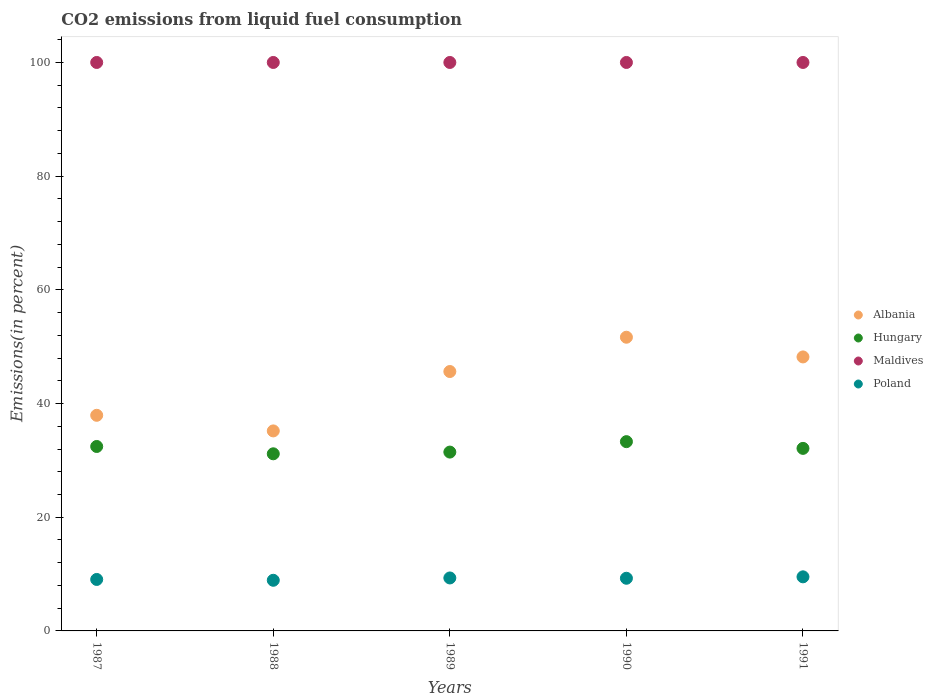How many different coloured dotlines are there?
Offer a very short reply. 4. What is the total CO2 emitted in Albania in 1991?
Offer a very short reply. 48.2. Across all years, what is the maximum total CO2 emitted in Hungary?
Your answer should be compact. 33.3. Across all years, what is the minimum total CO2 emitted in Hungary?
Offer a terse response. 31.16. What is the total total CO2 emitted in Hungary in the graph?
Your response must be concise. 160.47. What is the difference between the total CO2 emitted in Albania in 1988 and that in 1991?
Give a very brief answer. -13.01. What is the difference between the total CO2 emitted in Maldives in 1988 and the total CO2 emitted in Poland in 1989?
Your answer should be compact. 90.68. What is the average total CO2 emitted in Albania per year?
Provide a succinct answer. 43.72. In the year 1989, what is the difference between the total CO2 emitted in Poland and total CO2 emitted in Maldives?
Make the answer very short. -90.68. In how many years, is the total CO2 emitted in Albania greater than 80 %?
Keep it short and to the point. 0. What is the ratio of the total CO2 emitted in Poland in 1989 to that in 1991?
Offer a terse response. 0.98. Is the total CO2 emitted in Maldives in 1988 less than that in 1990?
Offer a very short reply. No. What is the difference between the highest and the second highest total CO2 emitted in Hungary?
Offer a terse response. 0.85. What is the difference between the highest and the lowest total CO2 emitted in Maldives?
Your response must be concise. 0. Does the total CO2 emitted in Poland monotonically increase over the years?
Your answer should be compact. No. Is the total CO2 emitted in Albania strictly greater than the total CO2 emitted in Hungary over the years?
Your response must be concise. Yes. Is the total CO2 emitted in Maldives strictly less than the total CO2 emitted in Poland over the years?
Give a very brief answer. No. Are the values on the major ticks of Y-axis written in scientific E-notation?
Your response must be concise. No. Does the graph contain any zero values?
Ensure brevity in your answer.  No. Does the graph contain grids?
Make the answer very short. No. Where does the legend appear in the graph?
Your answer should be compact. Center right. How are the legend labels stacked?
Offer a very short reply. Vertical. What is the title of the graph?
Provide a succinct answer. CO2 emissions from liquid fuel consumption. Does "Gambia, The" appear as one of the legend labels in the graph?
Your answer should be compact. No. What is the label or title of the X-axis?
Make the answer very short. Years. What is the label or title of the Y-axis?
Provide a short and direct response. Emissions(in percent). What is the Emissions(in percent) of Albania in 1987?
Provide a short and direct response. 37.93. What is the Emissions(in percent) of Hungary in 1987?
Make the answer very short. 32.45. What is the Emissions(in percent) in Poland in 1987?
Ensure brevity in your answer.  9.05. What is the Emissions(in percent) in Albania in 1988?
Your answer should be compact. 35.19. What is the Emissions(in percent) in Hungary in 1988?
Provide a short and direct response. 31.16. What is the Emissions(in percent) in Maldives in 1988?
Offer a very short reply. 100. What is the Emissions(in percent) of Poland in 1988?
Offer a very short reply. 8.91. What is the Emissions(in percent) of Albania in 1989?
Provide a succinct answer. 45.63. What is the Emissions(in percent) of Hungary in 1989?
Your answer should be compact. 31.46. What is the Emissions(in percent) in Poland in 1989?
Your answer should be compact. 9.32. What is the Emissions(in percent) in Albania in 1990?
Keep it short and to the point. 51.67. What is the Emissions(in percent) in Hungary in 1990?
Offer a very short reply. 33.3. What is the Emissions(in percent) in Poland in 1990?
Offer a terse response. 9.26. What is the Emissions(in percent) of Albania in 1991?
Ensure brevity in your answer.  48.2. What is the Emissions(in percent) in Hungary in 1991?
Provide a short and direct response. 32.11. What is the Emissions(in percent) in Poland in 1991?
Make the answer very short. 9.51. Across all years, what is the maximum Emissions(in percent) of Albania?
Your response must be concise. 51.67. Across all years, what is the maximum Emissions(in percent) in Hungary?
Provide a succinct answer. 33.3. Across all years, what is the maximum Emissions(in percent) of Poland?
Provide a short and direct response. 9.51. Across all years, what is the minimum Emissions(in percent) in Albania?
Offer a very short reply. 35.19. Across all years, what is the minimum Emissions(in percent) in Hungary?
Offer a very short reply. 31.16. Across all years, what is the minimum Emissions(in percent) in Poland?
Make the answer very short. 8.91. What is the total Emissions(in percent) of Albania in the graph?
Your answer should be compact. 218.61. What is the total Emissions(in percent) of Hungary in the graph?
Offer a very short reply. 160.47. What is the total Emissions(in percent) of Maldives in the graph?
Your answer should be compact. 500. What is the total Emissions(in percent) in Poland in the graph?
Your answer should be compact. 46.06. What is the difference between the Emissions(in percent) in Albania in 1987 and that in 1988?
Your answer should be very brief. 2.75. What is the difference between the Emissions(in percent) in Hungary in 1987 and that in 1988?
Your answer should be compact. 1.29. What is the difference between the Emissions(in percent) in Poland in 1987 and that in 1988?
Give a very brief answer. 0.15. What is the difference between the Emissions(in percent) of Albania in 1987 and that in 1989?
Give a very brief answer. -7.7. What is the difference between the Emissions(in percent) of Hungary in 1987 and that in 1989?
Provide a short and direct response. 0.99. What is the difference between the Emissions(in percent) in Maldives in 1987 and that in 1989?
Give a very brief answer. 0. What is the difference between the Emissions(in percent) in Poland in 1987 and that in 1989?
Keep it short and to the point. -0.26. What is the difference between the Emissions(in percent) in Albania in 1987 and that in 1990?
Keep it short and to the point. -13.73. What is the difference between the Emissions(in percent) of Hungary in 1987 and that in 1990?
Your response must be concise. -0.85. What is the difference between the Emissions(in percent) in Maldives in 1987 and that in 1990?
Offer a terse response. 0. What is the difference between the Emissions(in percent) in Poland in 1987 and that in 1990?
Offer a very short reply. -0.21. What is the difference between the Emissions(in percent) in Albania in 1987 and that in 1991?
Ensure brevity in your answer.  -10.27. What is the difference between the Emissions(in percent) of Hungary in 1987 and that in 1991?
Give a very brief answer. 0.33. What is the difference between the Emissions(in percent) in Maldives in 1987 and that in 1991?
Keep it short and to the point. 0. What is the difference between the Emissions(in percent) of Poland in 1987 and that in 1991?
Offer a very short reply. -0.46. What is the difference between the Emissions(in percent) of Albania in 1988 and that in 1989?
Ensure brevity in your answer.  -10.45. What is the difference between the Emissions(in percent) of Hungary in 1988 and that in 1989?
Provide a short and direct response. -0.3. What is the difference between the Emissions(in percent) in Maldives in 1988 and that in 1989?
Keep it short and to the point. 0. What is the difference between the Emissions(in percent) in Poland in 1988 and that in 1989?
Give a very brief answer. -0.41. What is the difference between the Emissions(in percent) in Albania in 1988 and that in 1990?
Make the answer very short. -16.48. What is the difference between the Emissions(in percent) of Hungary in 1988 and that in 1990?
Give a very brief answer. -2.14. What is the difference between the Emissions(in percent) of Poland in 1988 and that in 1990?
Your response must be concise. -0.36. What is the difference between the Emissions(in percent) in Albania in 1988 and that in 1991?
Your answer should be compact. -13.01. What is the difference between the Emissions(in percent) in Hungary in 1988 and that in 1991?
Offer a terse response. -0.95. What is the difference between the Emissions(in percent) in Maldives in 1988 and that in 1991?
Your answer should be compact. 0. What is the difference between the Emissions(in percent) in Poland in 1988 and that in 1991?
Make the answer very short. -0.61. What is the difference between the Emissions(in percent) in Albania in 1989 and that in 1990?
Provide a short and direct response. -6.03. What is the difference between the Emissions(in percent) in Hungary in 1989 and that in 1990?
Ensure brevity in your answer.  -1.84. What is the difference between the Emissions(in percent) of Poland in 1989 and that in 1990?
Provide a short and direct response. 0.05. What is the difference between the Emissions(in percent) of Albania in 1989 and that in 1991?
Make the answer very short. -2.57. What is the difference between the Emissions(in percent) in Hungary in 1989 and that in 1991?
Make the answer very short. -0.65. What is the difference between the Emissions(in percent) of Maldives in 1989 and that in 1991?
Make the answer very short. 0. What is the difference between the Emissions(in percent) in Poland in 1989 and that in 1991?
Provide a succinct answer. -0.2. What is the difference between the Emissions(in percent) in Albania in 1990 and that in 1991?
Offer a terse response. 3.47. What is the difference between the Emissions(in percent) of Hungary in 1990 and that in 1991?
Give a very brief answer. 1.18. What is the difference between the Emissions(in percent) in Maldives in 1990 and that in 1991?
Your answer should be compact. 0. What is the difference between the Emissions(in percent) in Poland in 1990 and that in 1991?
Offer a very short reply. -0.25. What is the difference between the Emissions(in percent) in Albania in 1987 and the Emissions(in percent) in Hungary in 1988?
Make the answer very short. 6.77. What is the difference between the Emissions(in percent) of Albania in 1987 and the Emissions(in percent) of Maldives in 1988?
Offer a very short reply. -62.07. What is the difference between the Emissions(in percent) in Albania in 1987 and the Emissions(in percent) in Poland in 1988?
Provide a short and direct response. 29.02. What is the difference between the Emissions(in percent) in Hungary in 1987 and the Emissions(in percent) in Maldives in 1988?
Your answer should be compact. -67.55. What is the difference between the Emissions(in percent) in Hungary in 1987 and the Emissions(in percent) in Poland in 1988?
Offer a very short reply. 23.54. What is the difference between the Emissions(in percent) in Maldives in 1987 and the Emissions(in percent) in Poland in 1988?
Make the answer very short. 91.09. What is the difference between the Emissions(in percent) in Albania in 1987 and the Emissions(in percent) in Hungary in 1989?
Offer a very short reply. 6.47. What is the difference between the Emissions(in percent) of Albania in 1987 and the Emissions(in percent) of Maldives in 1989?
Your answer should be very brief. -62.07. What is the difference between the Emissions(in percent) of Albania in 1987 and the Emissions(in percent) of Poland in 1989?
Your response must be concise. 28.61. What is the difference between the Emissions(in percent) in Hungary in 1987 and the Emissions(in percent) in Maldives in 1989?
Ensure brevity in your answer.  -67.55. What is the difference between the Emissions(in percent) in Hungary in 1987 and the Emissions(in percent) in Poland in 1989?
Keep it short and to the point. 23.13. What is the difference between the Emissions(in percent) in Maldives in 1987 and the Emissions(in percent) in Poland in 1989?
Your answer should be very brief. 90.68. What is the difference between the Emissions(in percent) in Albania in 1987 and the Emissions(in percent) in Hungary in 1990?
Offer a very short reply. 4.63. What is the difference between the Emissions(in percent) in Albania in 1987 and the Emissions(in percent) in Maldives in 1990?
Offer a terse response. -62.07. What is the difference between the Emissions(in percent) of Albania in 1987 and the Emissions(in percent) of Poland in 1990?
Your response must be concise. 28.67. What is the difference between the Emissions(in percent) of Hungary in 1987 and the Emissions(in percent) of Maldives in 1990?
Provide a short and direct response. -67.55. What is the difference between the Emissions(in percent) in Hungary in 1987 and the Emissions(in percent) in Poland in 1990?
Your answer should be compact. 23.18. What is the difference between the Emissions(in percent) of Maldives in 1987 and the Emissions(in percent) of Poland in 1990?
Ensure brevity in your answer.  90.74. What is the difference between the Emissions(in percent) in Albania in 1987 and the Emissions(in percent) in Hungary in 1991?
Offer a terse response. 5.82. What is the difference between the Emissions(in percent) in Albania in 1987 and the Emissions(in percent) in Maldives in 1991?
Provide a short and direct response. -62.07. What is the difference between the Emissions(in percent) of Albania in 1987 and the Emissions(in percent) of Poland in 1991?
Ensure brevity in your answer.  28.42. What is the difference between the Emissions(in percent) of Hungary in 1987 and the Emissions(in percent) of Maldives in 1991?
Offer a terse response. -67.55. What is the difference between the Emissions(in percent) of Hungary in 1987 and the Emissions(in percent) of Poland in 1991?
Give a very brief answer. 22.93. What is the difference between the Emissions(in percent) of Maldives in 1987 and the Emissions(in percent) of Poland in 1991?
Your answer should be very brief. 90.49. What is the difference between the Emissions(in percent) in Albania in 1988 and the Emissions(in percent) in Hungary in 1989?
Your response must be concise. 3.72. What is the difference between the Emissions(in percent) in Albania in 1988 and the Emissions(in percent) in Maldives in 1989?
Your answer should be very brief. -64.81. What is the difference between the Emissions(in percent) in Albania in 1988 and the Emissions(in percent) in Poland in 1989?
Offer a terse response. 25.87. What is the difference between the Emissions(in percent) of Hungary in 1988 and the Emissions(in percent) of Maldives in 1989?
Make the answer very short. -68.84. What is the difference between the Emissions(in percent) of Hungary in 1988 and the Emissions(in percent) of Poland in 1989?
Offer a very short reply. 21.84. What is the difference between the Emissions(in percent) of Maldives in 1988 and the Emissions(in percent) of Poland in 1989?
Make the answer very short. 90.68. What is the difference between the Emissions(in percent) in Albania in 1988 and the Emissions(in percent) in Hungary in 1990?
Keep it short and to the point. 1.89. What is the difference between the Emissions(in percent) of Albania in 1988 and the Emissions(in percent) of Maldives in 1990?
Your response must be concise. -64.81. What is the difference between the Emissions(in percent) of Albania in 1988 and the Emissions(in percent) of Poland in 1990?
Offer a very short reply. 25.92. What is the difference between the Emissions(in percent) in Hungary in 1988 and the Emissions(in percent) in Maldives in 1990?
Keep it short and to the point. -68.84. What is the difference between the Emissions(in percent) of Hungary in 1988 and the Emissions(in percent) of Poland in 1990?
Your response must be concise. 21.89. What is the difference between the Emissions(in percent) of Maldives in 1988 and the Emissions(in percent) of Poland in 1990?
Offer a terse response. 90.74. What is the difference between the Emissions(in percent) in Albania in 1988 and the Emissions(in percent) in Hungary in 1991?
Offer a very short reply. 3.07. What is the difference between the Emissions(in percent) in Albania in 1988 and the Emissions(in percent) in Maldives in 1991?
Provide a succinct answer. -64.81. What is the difference between the Emissions(in percent) in Albania in 1988 and the Emissions(in percent) in Poland in 1991?
Provide a succinct answer. 25.67. What is the difference between the Emissions(in percent) in Hungary in 1988 and the Emissions(in percent) in Maldives in 1991?
Your answer should be very brief. -68.84. What is the difference between the Emissions(in percent) in Hungary in 1988 and the Emissions(in percent) in Poland in 1991?
Your response must be concise. 21.64. What is the difference between the Emissions(in percent) of Maldives in 1988 and the Emissions(in percent) of Poland in 1991?
Ensure brevity in your answer.  90.49. What is the difference between the Emissions(in percent) in Albania in 1989 and the Emissions(in percent) in Hungary in 1990?
Offer a terse response. 12.34. What is the difference between the Emissions(in percent) of Albania in 1989 and the Emissions(in percent) of Maldives in 1990?
Offer a terse response. -54.37. What is the difference between the Emissions(in percent) in Albania in 1989 and the Emissions(in percent) in Poland in 1990?
Provide a succinct answer. 36.37. What is the difference between the Emissions(in percent) of Hungary in 1989 and the Emissions(in percent) of Maldives in 1990?
Provide a short and direct response. -68.54. What is the difference between the Emissions(in percent) of Hungary in 1989 and the Emissions(in percent) of Poland in 1990?
Give a very brief answer. 22.2. What is the difference between the Emissions(in percent) of Maldives in 1989 and the Emissions(in percent) of Poland in 1990?
Offer a terse response. 90.74. What is the difference between the Emissions(in percent) in Albania in 1989 and the Emissions(in percent) in Hungary in 1991?
Offer a very short reply. 13.52. What is the difference between the Emissions(in percent) of Albania in 1989 and the Emissions(in percent) of Maldives in 1991?
Your answer should be compact. -54.37. What is the difference between the Emissions(in percent) in Albania in 1989 and the Emissions(in percent) in Poland in 1991?
Offer a terse response. 36.12. What is the difference between the Emissions(in percent) of Hungary in 1989 and the Emissions(in percent) of Maldives in 1991?
Keep it short and to the point. -68.54. What is the difference between the Emissions(in percent) of Hungary in 1989 and the Emissions(in percent) of Poland in 1991?
Offer a very short reply. 21.95. What is the difference between the Emissions(in percent) of Maldives in 1989 and the Emissions(in percent) of Poland in 1991?
Provide a succinct answer. 90.49. What is the difference between the Emissions(in percent) in Albania in 1990 and the Emissions(in percent) in Hungary in 1991?
Your answer should be very brief. 19.55. What is the difference between the Emissions(in percent) of Albania in 1990 and the Emissions(in percent) of Maldives in 1991?
Your answer should be compact. -48.34. What is the difference between the Emissions(in percent) in Albania in 1990 and the Emissions(in percent) in Poland in 1991?
Your answer should be very brief. 42.15. What is the difference between the Emissions(in percent) in Hungary in 1990 and the Emissions(in percent) in Maldives in 1991?
Make the answer very short. -66.7. What is the difference between the Emissions(in percent) of Hungary in 1990 and the Emissions(in percent) of Poland in 1991?
Your response must be concise. 23.78. What is the difference between the Emissions(in percent) in Maldives in 1990 and the Emissions(in percent) in Poland in 1991?
Make the answer very short. 90.49. What is the average Emissions(in percent) of Albania per year?
Your answer should be very brief. 43.72. What is the average Emissions(in percent) of Hungary per year?
Your response must be concise. 32.09. What is the average Emissions(in percent) of Poland per year?
Ensure brevity in your answer.  9.21. In the year 1987, what is the difference between the Emissions(in percent) in Albania and Emissions(in percent) in Hungary?
Provide a short and direct response. 5.49. In the year 1987, what is the difference between the Emissions(in percent) of Albania and Emissions(in percent) of Maldives?
Offer a very short reply. -62.07. In the year 1987, what is the difference between the Emissions(in percent) in Albania and Emissions(in percent) in Poland?
Offer a terse response. 28.88. In the year 1987, what is the difference between the Emissions(in percent) in Hungary and Emissions(in percent) in Maldives?
Provide a short and direct response. -67.55. In the year 1987, what is the difference between the Emissions(in percent) in Hungary and Emissions(in percent) in Poland?
Your answer should be compact. 23.39. In the year 1987, what is the difference between the Emissions(in percent) in Maldives and Emissions(in percent) in Poland?
Keep it short and to the point. 90.95. In the year 1988, what is the difference between the Emissions(in percent) of Albania and Emissions(in percent) of Hungary?
Provide a succinct answer. 4.03. In the year 1988, what is the difference between the Emissions(in percent) in Albania and Emissions(in percent) in Maldives?
Your response must be concise. -64.81. In the year 1988, what is the difference between the Emissions(in percent) in Albania and Emissions(in percent) in Poland?
Offer a very short reply. 26.28. In the year 1988, what is the difference between the Emissions(in percent) in Hungary and Emissions(in percent) in Maldives?
Provide a short and direct response. -68.84. In the year 1988, what is the difference between the Emissions(in percent) of Hungary and Emissions(in percent) of Poland?
Provide a short and direct response. 22.25. In the year 1988, what is the difference between the Emissions(in percent) in Maldives and Emissions(in percent) in Poland?
Keep it short and to the point. 91.09. In the year 1989, what is the difference between the Emissions(in percent) in Albania and Emissions(in percent) in Hungary?
Your answer should be very brief. 14.17. In the year 1989, what is the difference between the Emissions(in percent) of Albania and Emissions(in percent) of Maldives?
Offer a terse response. -54.37. In the year 1989, what is the difference between the Emissions(in percent) in Albania and Emissions(in percent) in Poland?
Provide a succinct answer. 36.32. In the year 1989, what is the difference between the Emissions(in percent) in Hungary and Emissions(in percent) in Maldives?
Your response must be concise. -68.54. In the year 1989, what is the difference between the Emissions(in percent) of Hungary and Emissions(in percent) of Poland?
Offer a very short reply. 22.14. In the year 1989, what is the difference between the Emissions(in percent) of Maldives and Emissions(in percent) of Poland?
Offer a terse response. 90.68. In the year 1990, what is the difference between the Emissions(in percent) in Albania and Emissions(in percent) in Hungary?
Provide a succinct answer. 18.37. In the year 1990, what is the difference between the Emissions(in percent) of Albania and Emissions(in percent) of Maldives?
Make the answer very short. -48.34. In the year 1990, what is the difference between the Emissions(in percent) in Albania and Emissions(in percent) in Poland?
Ensure brevity in your answer.  42.4. In the year 1990, what is the difference between the Emissions(in percent) of Hungary and Emissions(in percent) of Maldives?
Provide a succinct answer. -66.7. In the year 1990, what is the difference between the Emissions(in percent) in Hungary and Emissions(in percent) in Poland?
Keep it short and to the point. 24.03. In the year 1990, what is the difference between the Emissions(in percent) of Maldives and Emissions(in percent) of Poland?
Ensure brevity in your answer.  90.74. In the year 1991, what is the difference between the Emissions(in percent) in Albania and Emissions(in percent) in Hungary?
Offer a very short reply. 16.09. In the year 1991, what is the difference between the Emissions(in percent) of Albania and Emissions(in percent) of Maldives?
Your answer should be very brief. -51.8. In the year 1991, what is the difference between the Emissions(in percent) of Albania and Emissions(in percent) of Poland?
Your answer should be compact. 38.68. In the year 1991, what is the difference between the Emissions(in percent) of Hungary and Emissions(in percent) of Maldives?
Provide a short and direct response. -67.89. In the year 1991, what is the difference between the Emissions(in percent) in Hungary and Emissions(in percent) in Poland?
Your answer should be very brief. 22.6. In the year 1991, what is the difference between the Emissions(in percent) of Maldives and Emissions(in percent) of Poland?
Provide a succinct answer. 90.49. What is the ratio of the Emissions(in percent) of Albania in 1987 to that in 1988?
Offer a very short reply. 1.08. What is the ratio of the Emissions(in percent) in Hungary in 1987 to that in 1988?
Give a very brief answer. 1.04. What is the ratio of the Emissions(in percent) in Poland in 1987 to that in 1988?
Provide a succinct answer. 1.02. What is the ratio of the Emissions(in percent) of Albania in 1987 to that in 1989?
Your response must be concise. 0.83. What is the ratio of the Emissions(in percent) in Hungary in 1987 to that in 1989?
Offer a terse response. 1.03. What is the ratio of the Emissions(in percent) in Poland in 1987 to that in 1989?
Give a very brief answer. 0.97. What is the ratio of the Emissions(in percent) in Albania in 1987 to that in 1990?
Your response must be concise. 0.73. What is the ratio of the Emissions(in percent) in Hungary in 1987 to that in 1990?
Your response must be concise. 0.97. What is the ratio of the Emissions(in percent) of Maldives in 1987 to that in 1990?
Your response must be concise. 1. What is the ratio of the Emissions(in percent) of Poland in 1987 to that in 1990?
Offer a very short reply. 0.98. What is the ratio of the Emissions(in percent) in Albania in 1987 to that in 1991?
Your response must be concise. 0.79. What is the ratio of the Emissions(in percent) in Hungary in 1987 to that in 1991?
Provide a short and direct response. 1.01. What is the ratio of the Emissions(in percent) of Maldives in 1987 to that in 1991?
Your answer should be very brief. 1. What is the ratio of the Emissions(in percent) of Poland in 1987 to that in 1991?
Offer a terse response. 0.95. What is the ratio of the Emissions(in percent) of Albania in 1988 to that in 1989?
Make the answer very short. 0.77. What is the ratio of the Emissions(in percent) of Poland in 1988 to that in 1989?
Your answer should be very brief. 0.96. What is the ratio of the Emissions(in percent) of Albania in 1988 to that in 1990?
Give a very brief answer. 0.68. What is the ratio of the Emissions(in percent) of Hungary in 1988 to that in 1990?
Provide a succinct answer. 0.94. What is the ratio of the Emissions(in percent) of Maldives in 1988 to that in 1990?
Provide a short and direct response. 1. What is the ratio of the Emissions(in percent) in Poland in 1988 to that in 1990?
Offer a terse response. 0.96. What is the ratio of the Emissions(in percent) in Albania in 1988 to that in 1991?
Ensure brevity in your answer.  0.73. What is the ratio of the Emissions(in percent) of Hungary in 1988 to that in 1991?
Offer a very short reply. 0.97. What is the ratio of the Emissions(in percent) in Poland in 1988 to that in 1991?
Your answer should be very brief. 0.94. What is the ratio of the Emissions(in percent) in Albania in 1989 to that in 1990?
Your answer should be very brief. 0.88. What is the ratio of the Emissions(in percent) in Hungary in 1989 to that in 1990?
Your answer should be compact. 0.94. What is the ratio of the Emissions(in percent) in Albania in 1989 to that in 1991?
Offer a terse response. 0.95. What is the ratio of the Emissions(in percent) of Hungary in 1989 to that in 1991?
Make the answer very short. 0.98. What is the ratio of the Emissions(in percent) of Maldives in 1989 to that in 1991?
Make the answer very short. 1. What is the ratio of the Emissions(in percent) in Poland in 1989 to that in 1991?
Give a very brief answer. 0.98. What is the ratio of the Emissions(in percent) in Albania in 1990 to that in 1991?
Offer a very short reply. 1.07. What is the ratio of the Emissions(in percent) in Hungary in 1990 to that in 1991?
Your answer should be very brief. 1.04. What is the ratio of the Emissions(in percent) of Maldives in 1990 to that in 1991?
Your answer should be very brief. 1. What is the ratio of the Emissions(in percent) in Poland in 1990 to that in 1991?
Ensure brevity in your answer.  0.97. What is the difference between the highest and the second highest Emissions(in percent) of Albania?
Your answer should be very brief. 3.47. What is the difference between the highest and the second highest Emissions(in percent) of Hungary?
Provide a short and direct response. 0.85. What is the difference between the highest and the second highest Emissions(in percent) in Poland?
Your response must be concise. 0.2. What is the difference between the highest and the lowest Emissions(in percent) in Albania?
Your answer should be very brief. 16.48. What is the difference between the highest and the lowest Emissions(in percent) of Hungary?
Offer a terse response. 2.14. What is the difference between the highest and the lowest Emissions(in percent) in Maldives?
Offer a terse response. 0. What is the difference between the highest and the lowest Emissions(in percent) in Poland?
Keep it short and to the point. 0.61. 